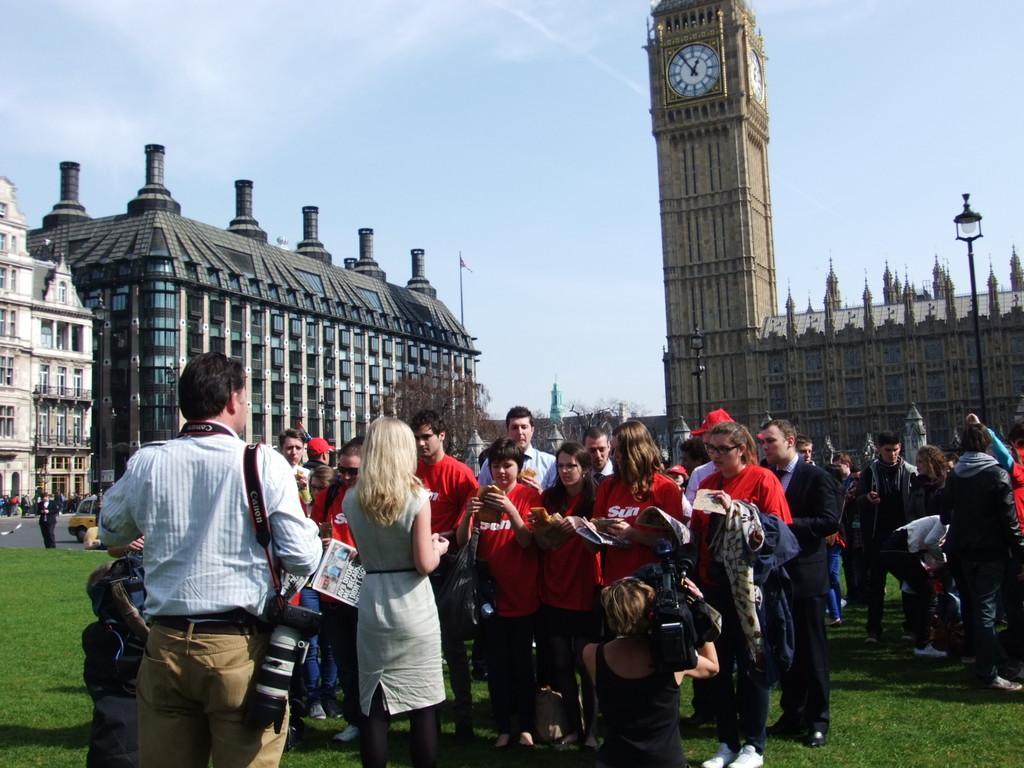In one or two sentences, can you explain what this image depicts? In this image I can see the group of people with different color dresses. To the left I can see the vehicle and few more people on the road. In the background I can see the buildings, trees and the sky. To the right I can see the pole. 